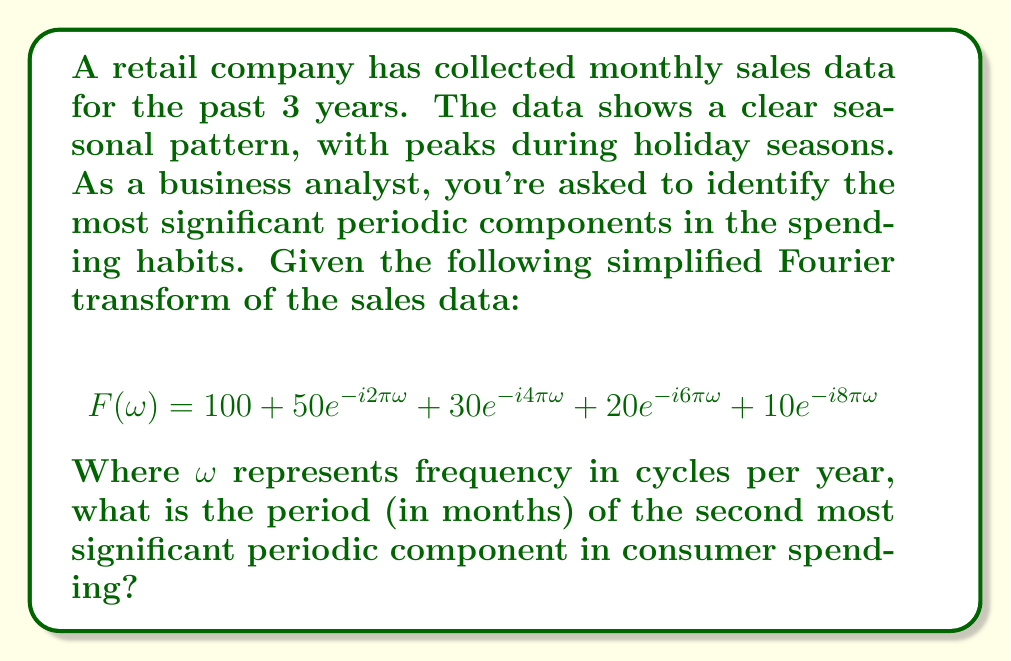Help me with this question. Let's approach this step-by-step:

1) In Fourier analysis, each term $ae^{-ib\pi\omega}$ represents a periodic component where:
   - $a$ is the amplitude (significance) of the component
   - $b\pi\omega$ represents the frequency

2) The components in our Fourier transform, ordered by amplitude, are:
   - $100$ (constant term)
   - $50e^{-i2\pi\omega}$
   - $30e^{-i4\pi\omega}$
   - $20e^{-i6\pi\omega}$
   - $10e^{-i8\pi\omega}$

3) The second most significant component (after the constant term) is $50e^{-i2\pi\omega}$

4) For this term, $b = 2$, meaning the frequency is $2\pi\omega$ cycles per year

5) To find the period, we use the relationship: period = 1 / frequency
   
   Period = $\frac{1}{2\pi\omega}$ years

6) To convert to months, we multiply by 12:
   
   Period = $\frac{12}{2\pi\omega}$ = $\frac{6}{\pi\omega}$ months

7) Since $\omega$ is in cycles per year, and we want a full cycle, we set $\omega = 1$:
   
   Period = $\frac{6}{\pi}$ months ≈ 1.91 months

8) Rounding to the nearest whole month, we get 2 months.
Answer: 2 months 